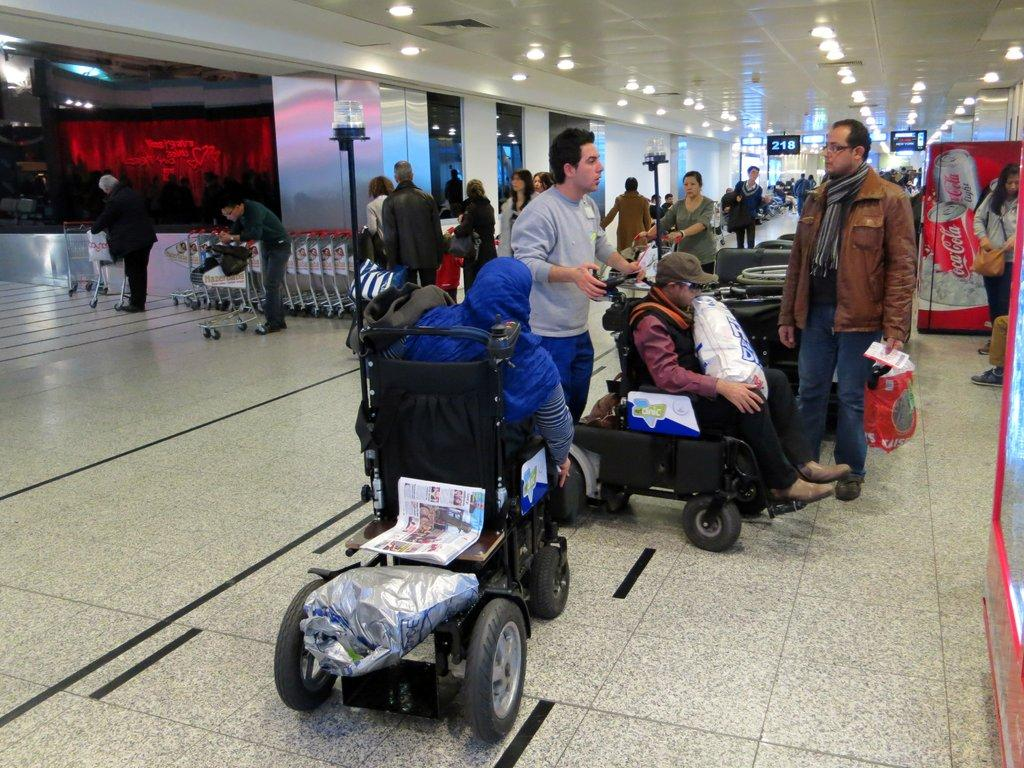Provide a one-sentence caption for the provided image. many people near a sign that says 218 in an airport. 